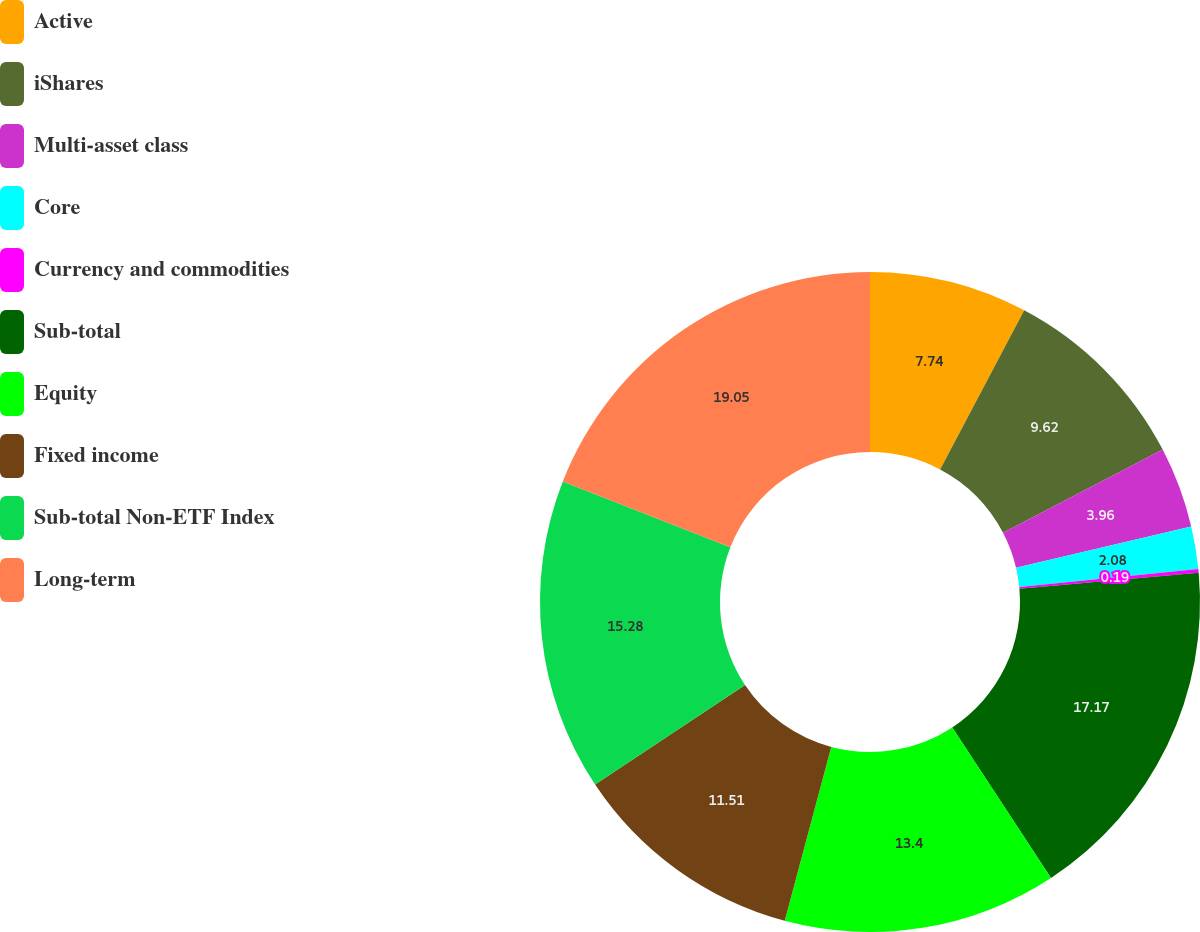Convert chart. <chart><loc_0><loc_0><loc_500><loc_500><pie_chart><fcel>Active<fcel>iShares<fcel>Multi-asset class<fcel>Core<fcel>Currency and commodities<fcel>Sub-total<fcel>Equity<fcel>Fixed income<fcel>Sub-total Non-ETF Index<fcel>Long-term<nl><fcel>7.74%<fcel>9.62%<fcel>3.96%<fcel>2.08%<fcel>0.19%<fcel>17.17%<fcel>13.4%<fcel>11.51%<fcel>15.28%<fcel>19.05%<nl></chart> 